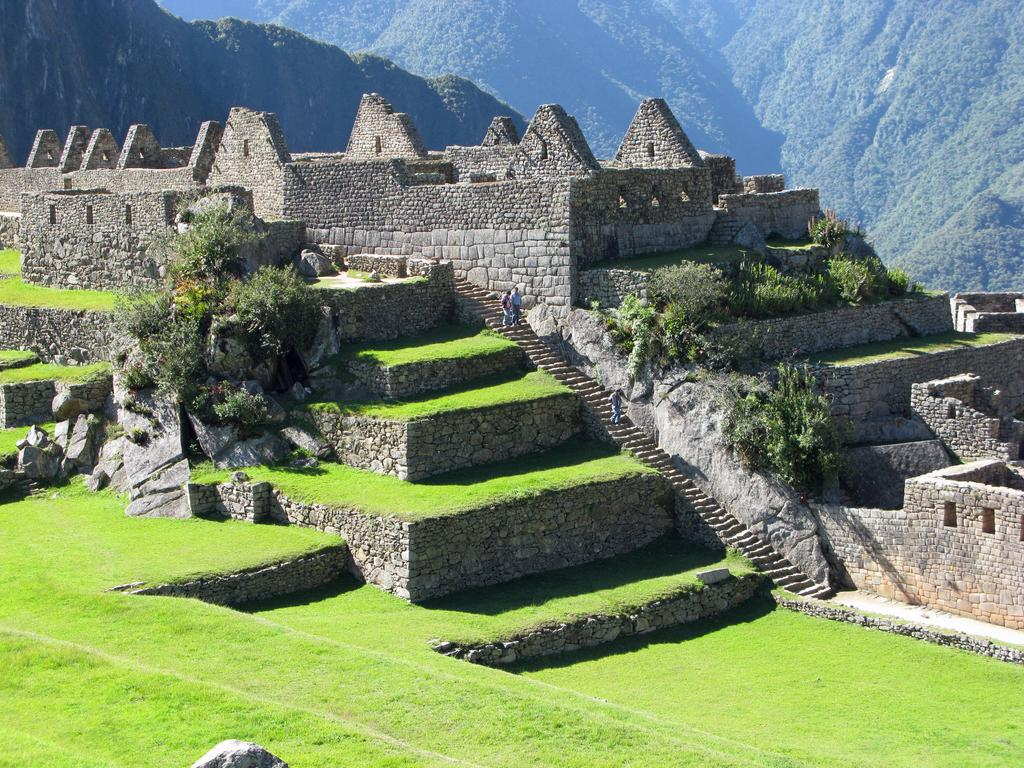What is the main subject in the middle of the image? There is a hyena picchu in the middle of the image. What can be seen in the distance behind the hyena picchu? There are mountains in the background of the image. What type of vegetation is present in the mountains? Trees and plants are present in the mountains. What type of ground is visible at the bottom of the image? There is grass at the bottom of the image. What verse is being recited by the hyena picchu in the image? There is no indication in the image that the hyena picchu is reciting a verse, so it cannot be determined from the picture. 